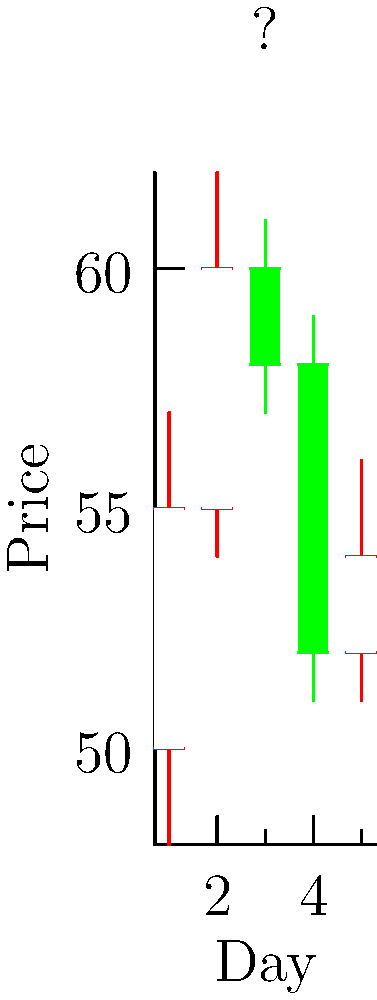Analyze the 5-day candlestick chart above. What bullish reversal pattern is forming, and what is the recommended action for a trader observing this pattern? To identify the pattern and determine the recommended action, let's analyze the chart step-by-step:

1. Day 1-2: We see two bullish (green) candlesticks with higher highs and higher lows, indicating an uptrend.

2. Day 3: A small bearish (red) candlestick forms, showing a potential slowdown in the upward momentum.

3. Day 4: A large bearish candlestick appears, with the closing price lower than the opening price of the previous day, suggesting a strong downward move.

4. Day 5: A small bullish candlestick forms, with its body entirely within the range of the previous day's bearish candlestick.

This 5-day pattern is known as a "Bullish Harami." The key characteristics are:
- A downtrend or at least a large down day (Day 4)
- A small candlestick (Day 5) that is completely contained within the body of the previous larger candlestick

The Bullish Harami suggests a potential reversal of the short-term downtrend. It indicates that sellers may be losing momentum and buyers are starting to enter the market.

For a trader observing this pattern, the recommended action would be to consider opening a long position (buy) with a stop-loss placed below the low of the Harami pattern (Day 4's low). However, it's crucial to wait for confirmation of the reversal, such as a bullish candlestick on the following day or other supporting technical indicators, before entering the trade.
Answer: Bullish Harami; Consider opening a long position with caution 